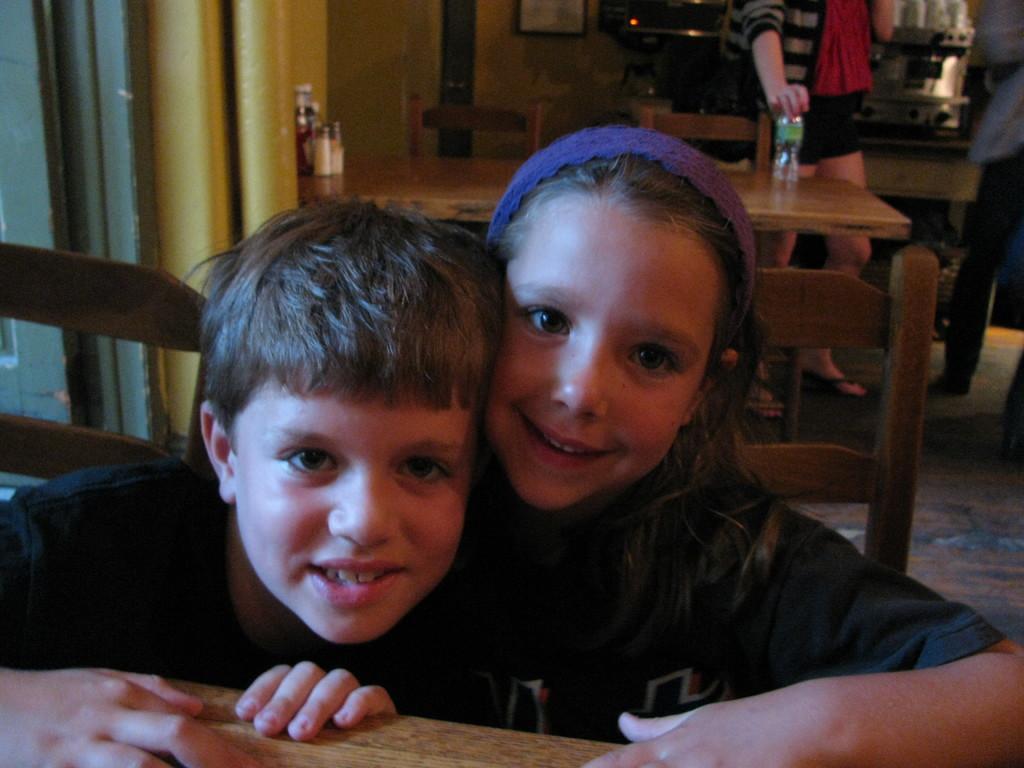In one or two sentences, can you explain what this image depicts? There are two children sitting on the chairs near the table. In the background we can see a person standing while holding a bottle. 